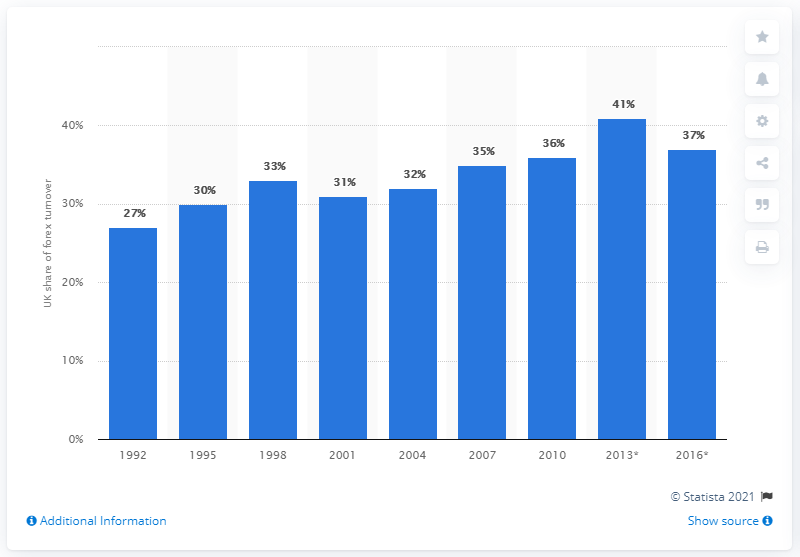Specify some key components in this picture. The UK's foreign exchange turnover share in 2013 was approximately 41%. In April 2016, the UK accounted for 37% of the international financial markets' foreign exchange turnover. 